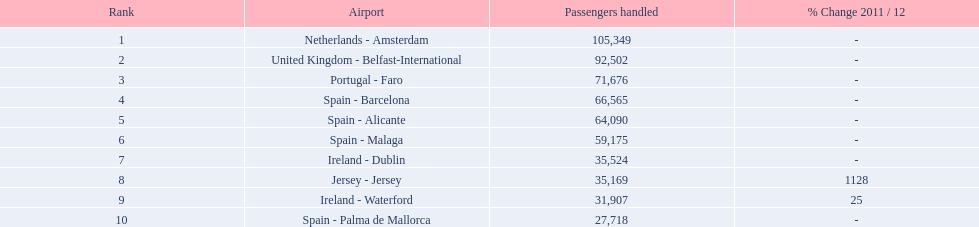What is the maximum number of passengers managed? 105,349. What is the destination of the passengers departing from the area that accommodates 105,349 travelers? Netherlands - Amsterdam. 